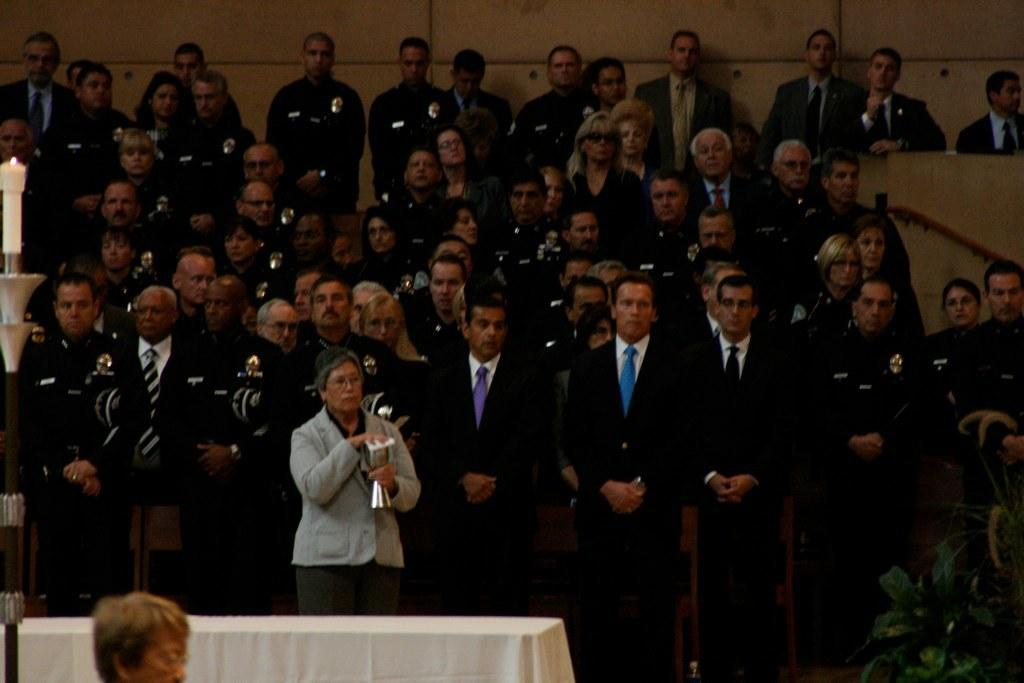What are the people in the image wearing? The people in the image are wearing coats. What is the person holding in the image? There is a person holding an object in the image. What is on the table in the image? There is a cloth on the table in the image. What type of plant can be seen in the image? There is a house plant in the image. What is the object on the table that might provide light? There is a candle stand in the image. How many fingers can be seen on the person holding the object in the image? There is no information about the number of fingers on the person holding the object in the image. What type of yam is present in the image? There is no yam present in the image. 